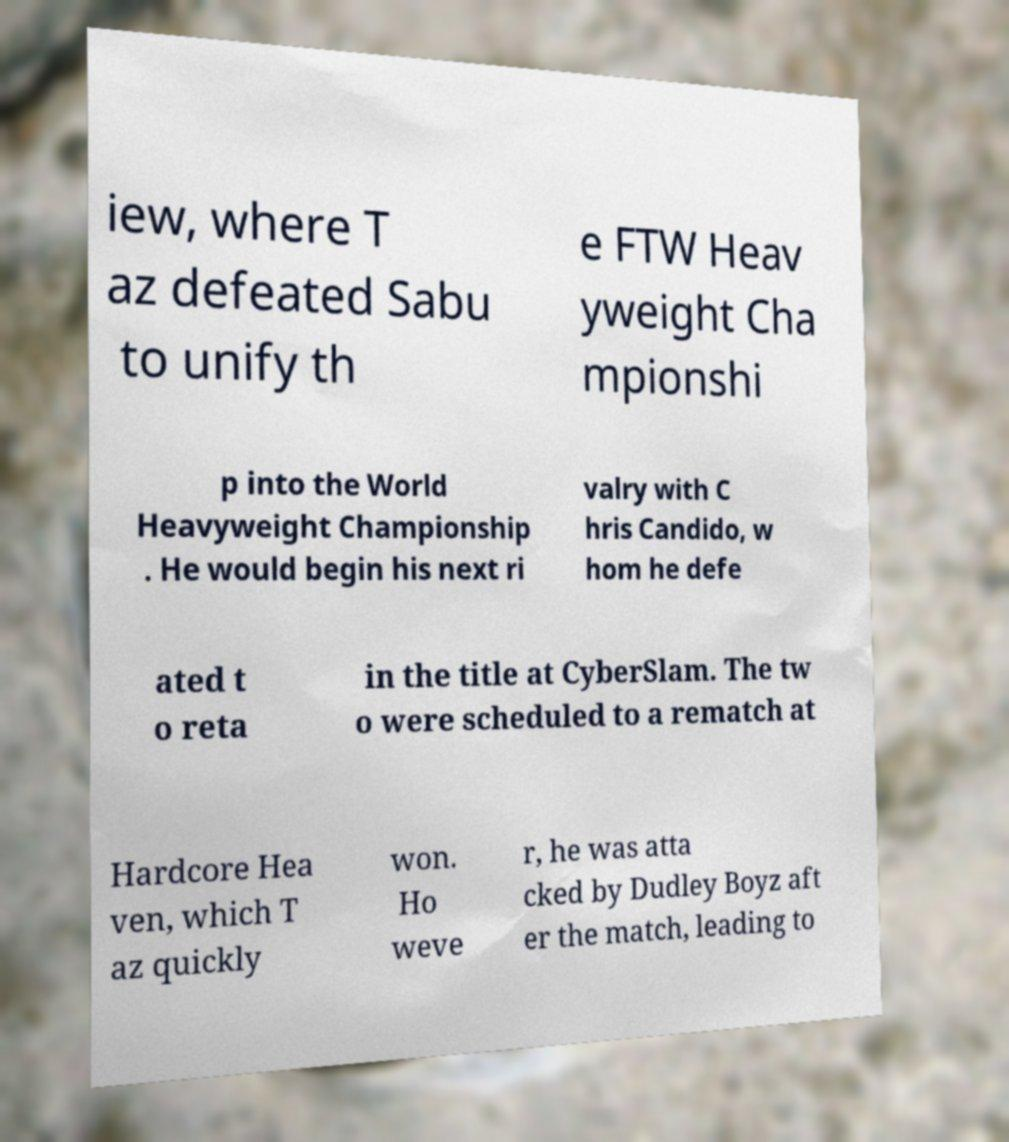For documentation purposes, I need the text within this image transcribed. Could you provide that? iew, where T az defeated Sabu to unify th e FTW Heav yweight Cha mpionshi p into the World Heavyweight Championship . He would begin his next ri valry with C hris Candido, w hom he defe ated t o reta in the title at CyberSlam. The tw o were scheduled to a rematch at Hardcore Hea ven, which T az quickly won. Ho weve r, he was atta cked by Dudley Boyz aft er the match, leading to 